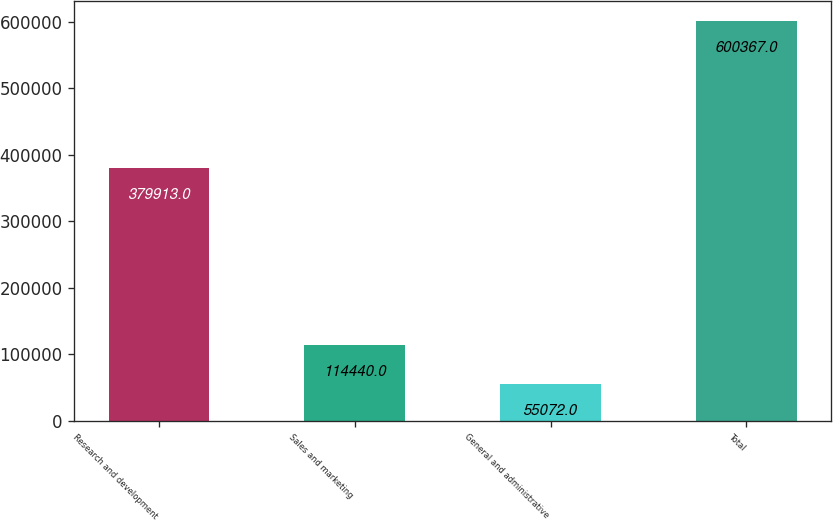<chart> <loc_0><loc_0><loc_500><loc_500><bar_chart><fcel>Research and development<fcel>Sales and marketing<fcel>General and administrative<fcel>Total<nl><fcel>379913<fcel>114440<fcel>55072<fcel>600367<nl></chart> 